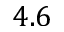<formula> <loc_0><loc_0><loc_500><loc_500>4 . 6</formula> 